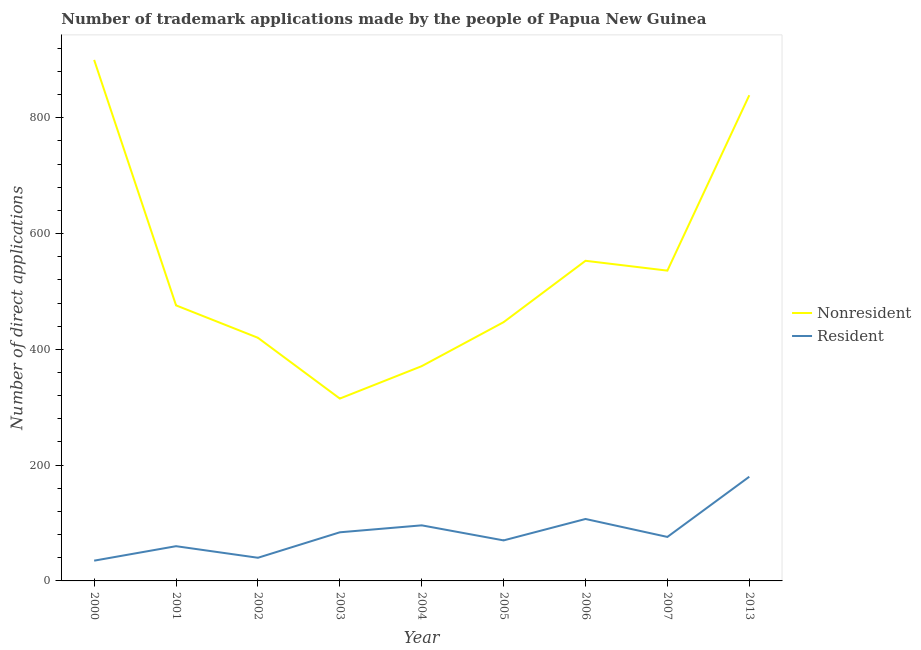What is the number of trademark applications made by non residents in 2002?
Give a very brief answer. 420. Across all years, what is the maximum number of trademark applications made by non residents?
Provide a succinct answer. 900. Across all years, what is the minimum number of trademark applications made by residents?
Offer a very short reply. 35. In which year was the number of trademark applications made by non residents maximum?
Your answer should be very brief. 2000. What is the total number of trademark applications made by residents in the graph?
Your answer should be very brief. 748. What is the difference between the number of trademark applications made by non residents in 2003 and that in 2013?
Your answer should be compact. -524. What is the difference between the number of trademark applications made by non residents in 2013 and the number of trademark applications made by residents in 2001?
Your answer should be compact. 779. What is the average number of trademark applications made by non residents per year?
Provide a short and direct response. 539.67. In the year 2001, what is the difference between the number of trademark applications made by residents and number of trademark applications made by non residents?
Your response must be concise. -416. In how many years, is the number of trademark applications made by residents greater than 320?
Offer a very short reply. 0. What is the ratio of the number of trademark applications made by residents in 2002 to that in 2013?
Ensure brevity in your answer.  0.22. What is the difference between the highest and the lowest number of trademark applications made by residents?
Offer a very short reply. 145. In how many years, is the number of trademark applications made by non residents greater than the average number of trademark applications made by non residents taken over all years?
Ensure brevity in your answer.  3. Is the sum of the number of trademark applications made by residents in 2000 and 2006 greater than the maximum number of trademark applications made by non residents across all years?
Make the answer very short. No. Does the number of trademark applications made by non residents monotonically increase over the years?
Make the answer very short. No. Is the number of trademark applications made by non residents strictly greater than the number of trademark applications made by residents over the years?
Your answer should be compact. Yes. What is the difference between two consecutive major ticks on the Y-axis?
Offer a very short reply. 200. Where does the legend appear in the graph?
Give a very brief answer. Center right. What is the title of the graph?
Provide a short and direct response. Number of trademark applications made by the people of Papua New Guinea. Does "Commercial service exports" appear as one of the legend labels in the graph?
Provide a succinct answer. No. What is the label or title of the Y-axis?
Your response must be concise. Number of direct applications. What is the Number of direct applications of Nonresident in 2000?
Provide a short and direct response. 900. What is the Number of direct applications in Nonresident in 2001?
Keep it short and to the point. 476. What is the Number of direct applications in Resident in 2001?
Your response must be concise. 60. What is the Number of direct applications in Nonresident in 2002?
Offer a terse response. 420. What is the Number of direct applications in Resident in 2002?
Your answer should be very brief. 40. What is the Number of direct applications of Nonresident in 2003?
Your answer should be compact. 315. What is the Number of direct applications of Nonresident in 2004?
Your response must be concise. 371. What is the Number of direct applications of Resident in 2004?
Offer a terse response. 96. What is the Number of direct applications of Nonresident in 2005?
Provide a short and direct response. 447. What is the Number of direct applications in Nonresident in 2006?
Provide a succinct answer. 553. What is the Number of direct applications in Resident in 2006?
Ensure brevity in your answer.  107. What is the Number of direct applications of Nonresident in 2007?
Keep it short and to the point. 536. What is the Number of direct applications of Resident in 2007?
Make the answer very short. 76. What is the Number of direct applications in Nonresident in 2013?
Keep it short and to the point. 839. What is the Number of direct applications of Resident in 2013?
Your response must be concise. 180. Across all years, what is the maximum Number of direct applications of Nonresident?
Provide a succinct answer. 900. Across all years, what is the maximum Number of direct applications in Resident?
Provide a succinct answer. 180. Across all years, what is the minimum Number of direct applications in Nonresident?
Give a very brief answer. 315. What is the total Number of direct applications in Nonresident in the graph?
Offer a terse response. 4857. What is the total Number of direct applications in Resident in the graph?
Provide a short and direct response. 748. What is the difference between the Number of direct applications in Nonresident in 2000 and that in 2001?
Provide a short and direct response. 424. What is the difference between the Number of direct applications of Resident in 2000 and that in 2001?
Provide a succinct answer. -25. What is the difference between the Number of direct applications of Nonresident in 2000 and that in 2002?
Offer a terse response. 480. What is the difference between the Number of direct applications in Resident in 2000 and that in 2002?
Offer a terse response. -5. What is the difference between the Number of direct applications in Nonresident in 2000 and that in 2003?
Offer a terse response. 585. What is the difference between the Number of direct applications in Resident in 2000 and that in 2003?
Your response must be concise. -49. What is the difference between the Number of direct applications in Nonresident in 2000 and that in 2004?
Keep it short and to the point. 529. What is the difference between the Number of direct applications of Resident in 2000 and that in 2004?
Ensure brevity in your answer.  -61. What is the difference between the Number of direct applications in Nonresident in 2000 and that in 2005?
Make the answer very short. 453. What is the difference between the Number of direct applications in Resident in 2000 and that in 2005?
Offer a very short reply. -35. What is the difference between the Number of direct applications in Nonresident in 2000 and that in 2006?
Provide a short and direct response. 347. What is the difference between the Number of direct applications of Resident in 2000 and that in 2006?
Your response must be concise. -72. What is the difference between the Number of direct applications in Nonresident in 2000 and that in 2007?
Provide a short and direct response. 364. What is the difference between the Number of direct applications in Resident in 2000 and that in 2007?
Provide a succinct answer. -41. What is the difference between the Number of direct applications in Nonresident in 2000 and that in 2013?
Ensure brevity in your answer.  61. What is the difference between the Number of direct applications in Resident in 2000 and that in 2013?
Offer a very short reply. -145. What is the difference between the Number of direct applications of Nonresident in 2001 and that in 2002?
Keep it short and to the point. 56. What is the difference between the Number of direct applications of Resident in 2001 and that in 2002?
Give a very brief answer. 20. What is the difference between the Number of direct applications of Nonresident in 2001 and that in 2003?
Your response must be concise. 161. What is the difference between the Number of direct applications in Resident in 2001 and that in 2003?
Provide a succinct answer. -24. What is the difference between the Number of direct applications in Nonresident in 2001 and that in 2004?
Your answer should be compact. 105. What is the difference between the Number of direct applications in Resident in 2001 and that in 2004?
Make the answer very short. -36. What is the difference between the Number of direct applications in Nonresident in 2001 and that in 2005?
Offer a very short reply. 29. What is the difference between the Number of direct applications of Resident in 2001 and that in 2005?
Your answer should be compact. -10. What is the difference between the Number of direct applications in Nonresident in 2001 and that in 2006?
Your answer should be compact. -77. What is the difference between the Number of direct applications in Resident in 2001 and that in 2006?
Your answer should be compact. -47. What is the difference between the Number of direct applications of Nonresident in 2001 and that in 2007?
Offer a terse response. -60. What is the difference between the Number of direct applications of Resident in 2001 and that in 2007?
Provide a short and direct response. -16. What is the difference between the Number of direct applications in Nonresident in 2001 and that in 2013?
Keep it short and to the point. -363. What is the difference between the Number of direct applications in Resident in 2001 and that in 2013?
Your response must be concise. -120. What is the difference between the Number of direct applications of Nonresident in 2002 and that in 2003?
Your response must be concise. 105. What is the difference between the Number of direct applications of Resident in 2002 and that in 2003?
Your answer should be compact. -44. What is the difference between the Number of direct applications of Resident in 2002 and that in 2004?
Make the answer very short. -56. What is the difference between the Number of direct applications in Nonresident in 2002 and that in 2006?
Your answer should be very brief. -133. What is the difference between the Number of direct applications of Resident in 2002 and that in 2006?
Make the answer very short. -67. What is the difference between the Number of direct applications of Nonresident in 2002 and that in 2007?
Offer a terse response. -116. What is the difference between the Number of direct applications of Resident in 2002 and that in 2007?
Give a very brief answer. -36. What is the difference between the Number of direct applications in Nonresident in 2002 and that in 2013?
Offer a very short reply. -419. What is the difference between the Number of direct applications in Resident in 2002 and that in 2013?
Your response must be concise. -140. What is the difference between the Number of direct applications of Nonresident in 2003 and that in 2004?
Your answer should be very brief. -56. What is the difference between the Number of direct applications in Nonresident in 2003 and that in 2005?
Ensure brevity in your answer.  -132. What is the difference between the Number of direct applications of Nonresident in 2003 and that in 2006?
Your response must be concise. -238. What is the difference between the Number of direct applications of Nonresident in 2003 and that in 2007?
Ensure brevity in your answer.  -221. What is the difference between the Number of direct applications of Nonresident in 2003 and that in 2013?
Provide a short and direct response. -524. What is the difference between the Number of direct applications in Resident in 2003 and that in 2013?
Provide a succinct answer. -96. What is the difference between the Number of direct applications in Nonresident in 2004 and that in 2005?
Provide a succinct answer. -76. What is the difference between the Number of direct applications in Nonresident in 2004 and that in 2006?
Make the answer very short. -182. What is the difference between the Number of direct applications in Nonresident in 2004 and that in 2007?
Offer a terse response. -165. What is the difference between the Number of direct applications of Resident in 2004 and that in 2007?
Ensure brevity in your answer.  20. What is the difference between the Number of direct applications in Nonresident in 2004 and that in 2013?
Keep it short and to the point. -468. What is the difference between the Number of direct applications in Resident in 2004 and that in 2013?
Provide a succinct answer. -84. What is the difference between the Number of direct applications of Nonresident in 2005 and that in 2006?
Offer a very short reply. -106. What is the difference between the Number of direct applications of Resident in 2005 and that in 2006?
Make the answer very short. -37. What is the difference between the Number of direct applications of Nonresident in 2005 and that in 2007?
Offer a very short reply. -89. What is the difference between the Number of direct applications of Resident in 2005 and that in 2007?
Give a very brief answer. -6. What is the difference between the Number of direct applications of Nonresident in 2005 and that in 2013?
Your answer should be compact. -392. What is the difference between the Number of direct applications of Resident in 2005 and that in 2013?
Offer a terse response. -110. What is the difference between the Number of direct applications in Nonresident in 2006 and that in 2007?
Your answer should be compact. 17. What is the difference between the Number of direct applications in Nonresident in 2006 and that in 2013?
Offer a terse response. -286. What is the difference between the Number of direct applications of Resident in 2006 and that in 2013?
Give a very brief answer. -73. What is the difference between the Number of direct applications in Nonresident in 2007 and that in 2013?
Offer a terse response. -303. What is the difference between the Number of direct applications in Resident in 2007 and that in 2013?
Offer a terse response. -104. What is the difference between the Number of direct applications of Nonresident in 2000 and the Number of direct applications of Resident in 2001?
Make the answer very short. 840. What is the difference between the Number of direct applications in Nonresident in 2000 and the Number of direct applications in Resident in 2002?
Provide a short and direct response. 860. What is the difference between the Number of direct applications in Nonresident in 2000 and the Number of direct applications in Resident in 2003?
Provide a succinct answer. 816. What is the difference between the Number of direct applications in Nonresident in 2000 and the Number of direct applications in Resident in 2004?
Make the answer very short. 804. What is the difference between the Number of direct applications in Nonresident in 2000 and the Number of direct applications in Resident in 2005?
Your answer should be very brief. 830. What is the difference between the Number of direct applications in Nonresident in 2000 and the Number of direct applications in Resident in 2006?
Make the answer very short. 793. What is the difference between the Number of direct applications in Nonresident in 2000 and the Number of direct applications in Resident in 2007?
Provide a succinct answer. 824. What is the difference between the Number of direct applications of Nonresident in 2000 and the Number of direct applications of Resident in 2013?
Give a very brief answer. 720. What is the difference between the Number of direct applications in Nonresident in 2001 and the Number of direct applications in Resident in 2002?
Your answer should be compact. 436. What is the difference between the Number of direct applications in Nonresident in 2001 and the Number of direct applications in Resident in 2003?
Give a very brief answer. 392. What is the difference between the Number of direct applications in Nonresident in 2001 and the Number of direct applications in Resident in 2004?
Your answer should be very brief. 380. What is the difference between the Number of direct applications in Nonresident in 2001 and the Number of direct applications in Resident in 2005?
Provide a succinct answer. 406. What is the difference between the Number of direct applications in Nonresident in 2001 and the Number of direct applications in Resident in 2006?
Your response must be concise. 369. What is the difference between the Number of direct applications of Nonresident in 2001 and the Number of direct applications of Resident in 2007?
Ensure brevity in your answer.  400. What is the difference between the Number of direct applications in Nonresident in 2001 and the Number of direct applications in Resident in 2013?
Give a very brief answer. 296. What is the difference between the Number of direct applications in Nonresident in 2002 and the Number of direct applications in Resident in 2003?
Your answer should be compact. 336. What is the difference between the Number of direct applications of Nonresident in 2002 and the Number of direct applications of Resident in 2004?
Ensure brevity in your answer.  324. What is the difference between the Number of direct applications of Nonresident in 2002 and the Number of direct applications of Resident in 2005?
Keep it short and to the point. 350. What is the difference between the Number of direct applications of Nonresident in 2002 and the Number of direct applications of Resident in 2006?
Offer a terse response. 313. What is the difference between the Number of direct applications of Nonresident in 2002 and the Number of direct applications of Resident in 2007?
Give a very brief answer. 344. What is the difference between the Number of direct applications of Nonresident in 2002 and the Number of direct applications of Resident in 2013?
Keep it short and to the point. 240. What is the difference between the Number of direct applications of Nonresident in 2003 and the Number of direct applications of Resident in 2004?
Provide a succinct answer. 219. What is the difference between the Number of direct applications of Nonresident in 2003 and the Number of direct applications of Resident in 2005?
Provide a short and direct response. 245. What is the difference between the Number of direct applications in Nonresident in 2003 and the Number of direct applications in Resident in 2006?
Offer a very short reply. 208. What is the difference between the Number of direct applications of Nonresident in 2003 and the Number of direct applications of Resident in 2007?
Offer a terse response. 239. What is the difference between the Number of direct applications in Nonresident in 2003 and the Number of direct applications in Resident in 2013?
Offer a very short reply. 135. What is the difference between the Number of direct applications in Nonresident in 2004 and the Number of direct applications in Resident in 2005?
Offer a very short reply. 301. What is the difference between the Number of direct applications in Nonresident in 2004 and the Number of direct applications in Resident in 2006?
Offer a terse response. 264. What is the difference between the Number of direct applications in Nonresident in 2004 and the Number of direct applications in Resident in 2007?
Your answer should be compact. 295. What is the difference between the Number of direct applications of Nonresident in 2004 and the Number of direct applications of Resident in 2013?
Offer a very short reply. 191. What is the difference between the Number of direct applications of Nonresident in 2005 and the Number of direct applications of Resident in 2006?
Your answer should be compact. 340. What is the difference between the Number of direct applications in Nonresident in 2005 and the Number of direct applications in Resident in 2007?
Your answer should be compact. 371. What is the difference between the Number of direct applications in Nonresident in 2005 and the Number of direct applications in Resident in 2013?
Your answer should be very brief. 267. What is the difference between the Number of direct applications in Nonresident in 2006 and the Number of direct applications in Resident in 2007?
Provide a short and direct response. 477. What is the difference between the Number of direct applications in Nonresident in 2006 and the Number of direct applications in Resident in 2013?
Offer a terse response. 373. What is the difference between the Number of direct applications of Nonresident in 2007 and the Number of direct applications of Resident in 2013?
Keep it short and to the point. 356. What is the average Number of direct applications of Nonresident per year?
Your response must be concise. 539.67. What is the average Number of direct applications in Resident per year?
Give a very brief answer. 83.11. In the year 2000, what is the difference between the Number of direct applications in Nonresident and Number of direct applications in Resident?
Provide a succinct answer. 865. In the year 2001, what is the difference between the Number of direct applications in Nonresident and Number of direct applications in Resident?
Offer a terse response. 416. In the year 2002, what is the difference between the Number of direct applications of Nonresident and Number of direct applications of Resident?
Offer a terse response. 380. In the year 2003, what is the difference between the Number of direct applications of Nonresident and Number of direct applications of Resident?
Ensure brevity in your answer.  231. In the year 2004, what is the difference between the Number of direct applications in Nonresident and Number of direct applications in Resident?
Offer a very short reply. 275. In the year 2005, what is the difference between the Number of direct applications in Nonresident and Number of direct applications in Resident?
Provide a short and direct response. 377. In the year 2006, what is the difference between the Number of direct applications of Nonresident and Number of direct applications of Resident?
Your response must be concise. 446. In the year 2007, what is the difference between the Number of direct applications in Nonresident and Number of direct applications in Resident?
Offer a terse response. 460. In the year 2013, what is the difference between the Number of direct applications in Nonresident and Number of direct applications in Resident?
Your answer should be compact. 659. What is the ratio of the Number of direct applications in Nonresident in 2000 to that in 2001?
Provide a succinct answer. 1.89. What is the ratio of the Number of direct applications in Resident in 2000 to that in 2001?
Provide a short and direct response. 0.58. What is the ratio of the Number of direct applications of Nonresident in 2000 to that in 2002?
Your answer should be very brief. 2.14. What is the ratio of the Number of direct applications in Resident in 2000 to that in 2002?
Your answer should be very brief. 0.88. What is the ratio of the Number of direct applications in Nonresident in 2000 to that in 2003?
Your answer should be very brief. 2.86. What is the ratio of the Number of direct applications in Resident in 2000 to that in 2003?
Your answer should be very brief. 0.42. What is the ratio of the Number of direct applications of Nonresident in 2000 to that in 2004?
Ensure brevity in your answer.  2.43. What is the ratio of the Number of direct applications in Resident in 2000 to that in 2004?
Ensure brevity in your answer.  0.36. What is the ratio of the Number of direct applications in Nonresident in 2000 to that in 2005?
Provide a short and direct response. 2.01. What is the ratio of the Number of direct applications of Resident in 2000 to that in 2005?
Provide a succinct answer. 0.5. What is the ratio of the Number of direct applications of Nonresident in 2000 to that in 2006?
Offer a very short reply. 1.63. What is the ratio of the Number of direct applications in Resident in 2000 to that in 2006?
Provide a succinct answer. 0.33. What is the ratio of the Number of direct applications of Nonresident in 2000 to that in 2007?
Offer a very short reply. 1.68. What is the ratio of the Number of direct applications in Resident in 2000 to that in 2007?
Give a very brief answer. 0.46. What is the ratio of the Number of direct applications in Nonresident in 2000 to that in 2013?
Offer a terse response. 1.07. What is the ratio of the Number of direct applications of Resident in 2000 to that in 2013?
Your answer should be very brief. 0.19. What is the ratio of the Number of direct applications in Nonresident in 2001 to that in 2002?
Provide a short and direct response. 1.13. What is the ratio of the Number of direct applications of Nonresident in 2001 to that in 2003?
Your answer should be compact. 1.51. What is the ratio of the Number of direct applications of Nonresident in 2001 to that in 2004?
Provide a short and direct response. 1.28. What is the ratio of the Number of direct applications of Nonresident in 2001 to that in 2005?
Your response must be concise. 1.06. What is the ratio of the Number of direct applications of Nonresident in 2001 to that in 2006?
Make the answer very short. 0.86. What is the ratio of the Number of direct applications of Resident in 2001 to that in 2006?
Ensure brevity in your answer.  0.56. What is the ratio of the Number of direct applications in Nonresident in 2001 to that in 2007?
Provide a succinct answer. 0.89. What is the ratio of the Number of direct applications in Resident in 2001 to that in 2007?
Provide a short and direct response. 0.79. What is the ratio of the Number of direct applications of Nonresident in 2001 to that in 2013?
Offer a very short reply. 0.57. What is the ratio of the Number of direct applications in Resident in 2001 to that in 2013?
Offer a very short reply. 0.33. What is the ratio of the Number of direct applications of Nonresident in 2002 to that in 2003?
Ensure brevity in your answer.  1.33. What is the ratio of the Number of direct applications in Resident in 2002 to that in 2003?
Offer a very short reply. 0.48. What is the ratio of the Number of direct applications in Nonresident in 2002 to that in 2004?
Give a very brief answer. 1.13. What is the ratio of the Number of direct applications in Resident in 2002 to that in 2004?
Provide a short and direct response. 0.42. What is the ratio of the Number of direct applications of Nonresident in 2002 to that in 2005?
Provide a short and direct response. 0.94. What is the ratio of the Number of direct applications of Resident in 2002 to that in 2005?
Keep it short and to the point. 0.57. What is the ratio of the Number of direct applications in Nonresident in 2002 to that in 2006?
Offer a very short reply. 0.76. What is the ratio of the Number of direct applications of Resident in 2002 to that in 2006?
Give a very brief answer. 0.37. What is the ratio of the Number of direct applications in Nonresident in 2002 to that in 2007?
Keep it short and to the point. 0.78. What is the ratio of the Number of direct applications of Resident in 2002 to that in 2007?
Ensure brevity in your answer.  0.53. What is the ratio of the Number of direct applications in Nonresident in 2002 to that in 2013?
Provide a succinct answer. 0.5. What is the ratio of the Number of direct applications of Resident in 2002 to that in 2013?
Keep it short and to the point. 0.22. What is the ratio of the Number of direct applications of Nonresident in 2003 to that in 2004?
Ensure brevity in your answer.  0.85. What is the ratio of the Number of direct applications of Nonresident in 2003 to that in 2005?
Provide a succinct answer. 0.7. What is the ratio of the Number of direct applications of Resident in 2003 to that in 2005?
Your response must be concise. 1.2. What is the ratio of the Number of direct applications of Nonresident in 2003 to that in 2006?
Your answer should be very brief. 0.57. What is the ratio of the Number of direct applications in Resident in 2003 to that in 2006?
Your answer should be compact. 0.79. What is the ratio of the Number of direct applications of Nonresident in 2003 to that in 2007?
Provide a succinct answer. 0.59. What is the ratio of the Number of direct applications of Resident in 2003 to that in 2007?
Keep it short and to the point. 1.11. What is the ratio of the Number of direct applications in Nonresident in 2003 to that in 2013?
Make the answer very short. 0.38. What is the ratio of the Number of direct applications of Resident in 2003 to that in 2013?
Keep it short and to the point. 0.47. What is the ratio of the Number of direct applications in Nonresident in 2004 to that in 2005?
Offer a very short reply. 0.83. What is the ratio of the Number of direct applications of Resident in 2004 to that in 2005?
Provide a succinct answer. 1.37. What is the ratio of the Number of direct applications in Nonresident in 2004 to that in 2006?
Your answer should be very brief. 0.67. What is the ratio of the Number of direct applications of Resident in 2004 to that in 2006?
Give a very brief answer. 0.9. What is the ratio of the Number of direct applications of Nonresident in 2004 to that in 2007?
Provide a short and direct response. 0.69. What is the ratio of the Number of direct applications of Resident in 2004 to that in 2007?
Your answer should be very brief. 1.26. What is the ratio of the Number of direct applications in Nonresident in 2004 to that in 2013?
Make the answer very short. 0.44. What is the ratio of the Number of direct applications of Resident in 2004 to that in 2013?
Keep it short and to the point. 0.53. What is the ratio of the Number of direct applications of Nonresident in 2005 to that in 2006?
Keep it short and to the point. 0.81. What is the ratio of the Number of direct applications in Resident in 2005 to that in 2006?
Ensure brevity in your answer.  0.65. What is the ratio of the Number of direct applications in Nonresident in 2005 to that in 2007?
Offer a very short reply. 0.83. What is the ratio of the Number of direct applications in Resident in 2005 to that in 2007?
Give a very brief answer. 0.92. What is the ratio of the Number of direct applications of Nonresident in 2005 to that in 2013?
Offer a very short reply. 0.53. What is the ratio of the Number of direct applications of Resident in 2005 to that in 2013?
Offer a terse response. 0.39. What is the ratio of the Number of direct applications in Nonresident in 2006 to that in 2007?
Give a very brief answer. 1.03. What is the ratio of the Number of direct applications of Resident in 2006 to that in 2007?
Offer a very short reply. 1.41. What is the ratio of the Number of direct applications in Nonresident in 2006 to that in 2013?
Your response must be concise. 0.66. What is the ratio of the Number of direct applications in Resident in 2006 to that in 2013?
Your answer should be compact. 0.59. What is the ratio of the Number of direct applications in Nonresident in 2007 to that in 2013?
Your answer should be very brief. 0.64. What is the ratio of the Number of direct applications in Resident in 2007 to that in 2013?
Keep it short and to the point. 0.42. What is the difference between the highest and the second highest Number of direct applications of Resident?
Your response must be concise. 73. What is the difference between the highest and the lowest Number of direct applications in Nonresident?
Your answer should be very brief. 585. What is the difference between the highest and the lowest Number of direct applications in Resident?
Your response must be concise. 145. 